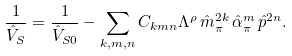<formula> <loc_0><loc_0><loc_500><loc_500>\frac { 1 } { \hat { V } _ { S } } = \frac { 1 } { \hat { V } _ { S 0 } } - \sum _ { k , m , n } C _ { k m n } \Lambda ^ { \rho } \, \hat { m } _ { \pi } ^ { 2 k } \, \hat { \alpha } _ { \pi } ^ { m } \, \hat { p } ^ { 2 n } .</formula> 